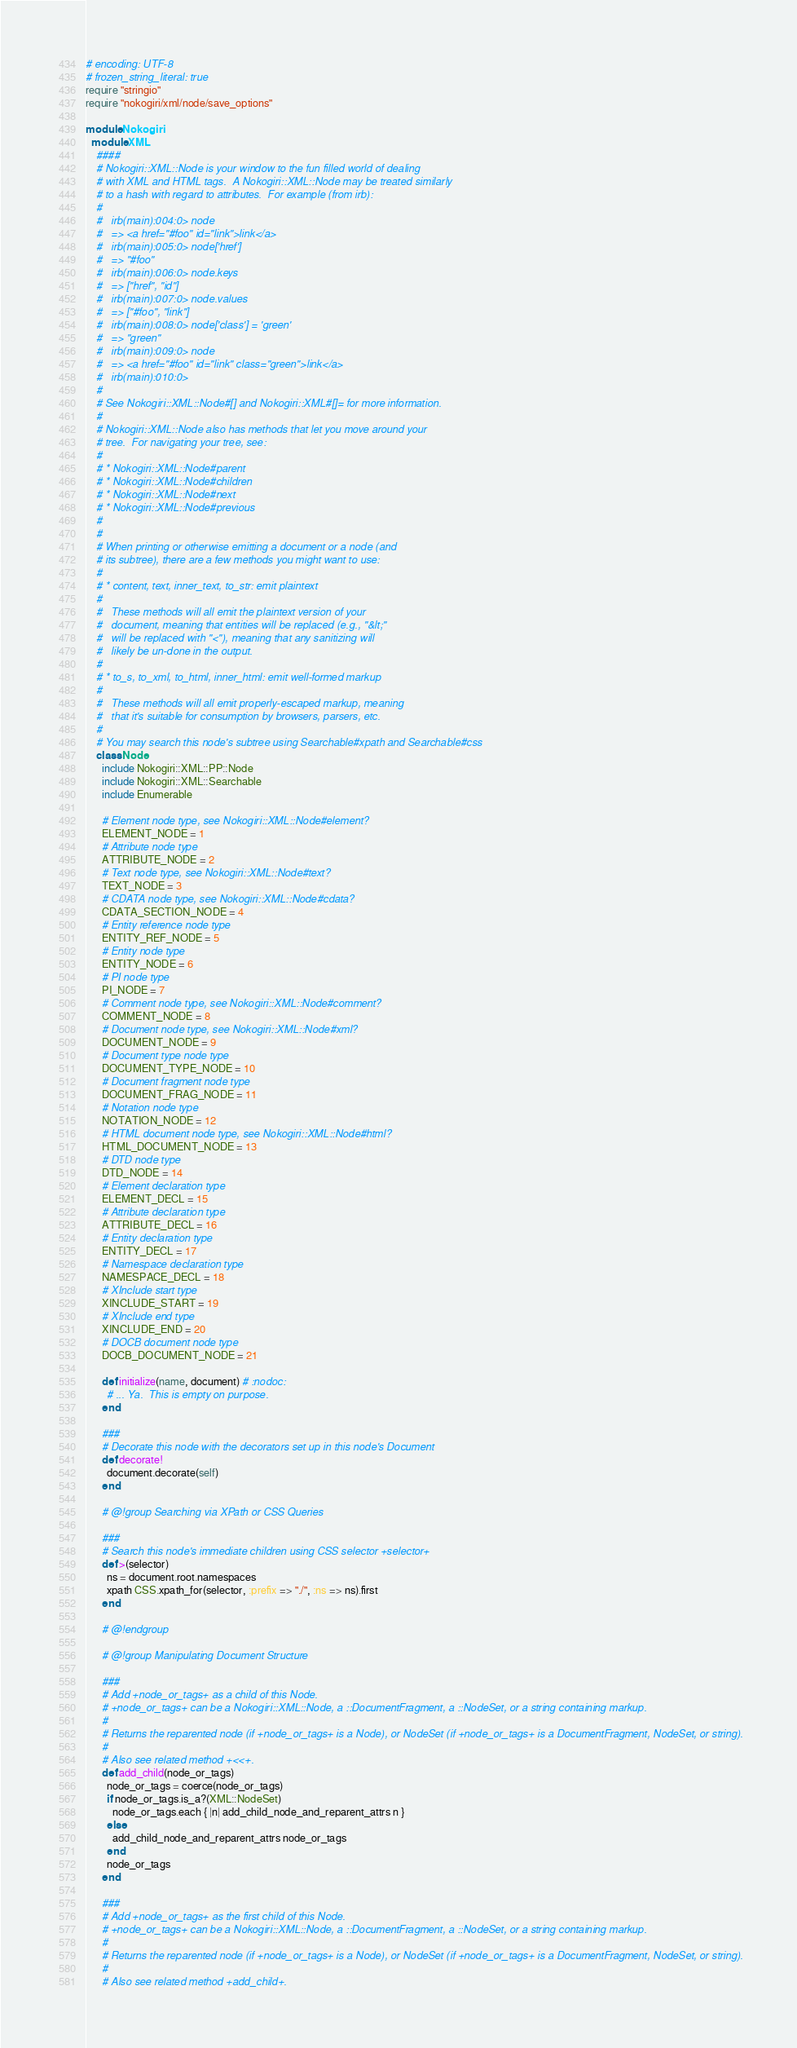<code> <loc_0><loc_0><loc_500><loc_500><_Ruby_># encoding: UTF-8
# frozen_string_literal: true
require "stringio"
require "nokogiri/xml/node/save_options"

module Nokogiri
  module XML
    ####
    # Nokogiri::XML::Node is your window to the fun filled world of dealing
    # with XML and HTML tags.  A Nokogiri::XML::Node may be treated similarly
    # to a hash with regard to attributes.  For example (from irb):
    #
    #   irb(main):004:0> node
    #   => <a href="#foo" id="link">link</a>
    #   irb(main):005:0> node['href']
    #   => "#foo"
    #   irb(main):006:0> node.keys
    #   => ["href", "id"]
    #   irb(main):007:0> node.values
    #   => ["#foo", "link"]
    #   irb(main):008:0> node['class'] = 'green'
    #   => "green"
    #   irb(main):009:0> node
    #   => <a href="#foo" id="link" class="green">link</a>
    #   irb(main):010:0>
    #
    # See Nokogiri::XML::Node#[] and Nokogiri::XML#[]= for more information.
    #
    # Nokogiri::XML::Node also has methods that let you move around your
    # tree.  For navigating your tree, see:
    #
    # * Nokogiri::XML::Node#parent
    # * Nokogiri::XML::Node#children
    # * Nokogiri::XML::Node#next
    # * Nokogiri::XML::Node#previous
    #
    #
    # When printing or otherwise emitting a document or a node (and
    # its subtree), there are a few methods you might want to use:
    #
    # * content, text, inner_text, to_str: emit plaintext
    #
    #   These methods will all emit the plaintext version of your
    #   document, meaning that entities will be replaced (e.g., "&lt;"
    #   will be replaced with "<"), meaning that any sanitizing will
    #   likely be un-done in the output.
    #
    # * to_s, to_xml, to_html, inner_html: emit well-formed markup
    #
    #   These methods will all emit properly-escaped markup, meaning
    #   that it's suitable for consumption by browsers, parsers, etc.
    #
    # You may search this node's subtree using Searchable#xpath and Searchable#css
    class Node
      include Nokogiri::XML::PP::Node
      include Nokogiri::XML::Searchable
      include Enumerable

      # Element node type, see Nokogiri::XML::Node#element?
      ELEMENT_NODE = 1
      # Attribute node type
      ATTRIBUTE_NODE = 2
      # Text node type, see Nokogiri::XML::Node#text?
      TEXT_NODE = 3
      # CDATA node type, see Nokogiri::XML::Node#cdata?
      CDATA_SECTION_NODE = 4
      # Entity reference node type
      ENTITY_REF_NODE = 5
      # Entity node type
      ENTITY_NODE = 6
      # PI node type
      PI_NODE = 7
      # Comment node type, see Nokogiri::XML::Node#comment?
      COMMENT_NODE = 8
      # Document node type, see Nokogiri::XML::Node#xml?
      DOCUMENT_NODE = 9
      # Document type node type
      DOCUMENT_TYPE_NODE = 10
      # Document fragment node type
      DOCUMENT_FRAG_NODE = 11
      # Notation node type
      NOTATION_NODE = 12
      # HTML document node type, see Nokogiri::XML::Node#html?
      HTML_DOCUMENT_NODE = 13
      # DTD node type
      DTD_NODE = 14
      # Element declaration type
      ELEMENT_DECL = 15
      # Attribute declaration type
      ATTRIBUTE_DECL = 16
      # Entity declaration type
      ENTITY_DECL = 17
      # Namespace declaration type
      NAMESPACE_DECL = 18
      # XInclude start type
      XINCLUDE_START = 19
      # XInclude end type
      XINCLUDE_END = 20
      # DOCB document node type
      DOCB_DOCUMENT_NODE = 21

      def initialize(name, document) # :nodoc:
        # ... Ya.  This is empty on purpose.
      end

      ###
      # Decorate this node with the decorators set up in this node's Document
      def decorate!
        document.decorate(self)
      end

      # @!group Searching via XPath or CSS Queries

      ###
      # Search this node's immediate children using CSS selector +selector+
      def >(selector)
        ns = document.root.namespaces
        xpath CSS.xpath_for(selector, :prefix => "./", :ns => ns).first
      end

      # @!endgroup

      # @!group Manipulating Document Structure

      ###
      # Add +node_or_tags+ as a child of this Node.
      # +node_or_tags+ can be a Nokogiri::XML::Node, a ::DocumentFragment, a ::NodeSet, or a string containing markup.
      #
      # Returns the reparented node (if +node_or_tags+ is a Node), or NodeSet (if +node_or_tags+ is a DocumentFragment, NodeSet, or string).
      #
      # Also see related method +<<+.
      def add_child(node_or_tags)
        node_or_tags = coerce(node_or_tags)
        if node_or_tags.is_a?(XML::NodeSet)
          node_or_tags.each { |n| add_child_node_and_reparent_attrs n }
        else
          add_child_node_and_reparent_attrs node_or_tags
        end
        node_or_tags
      end

      ###
      # Add +node_or_tags+ as the first child of this Node.
      # +node_or_tags+ can be a Nokogiri::XML::Node, a ::DocumentFragment, a ::NodeSet, or a string containing markup.
      #
      # Returns the reparented node (if +node_or_tags+ is a Node), or NodeSet (if +node_or_tags+ is a DocumentFragment, NodeSet, or string).
      #
      # Also see related method +add_child+.</code> 